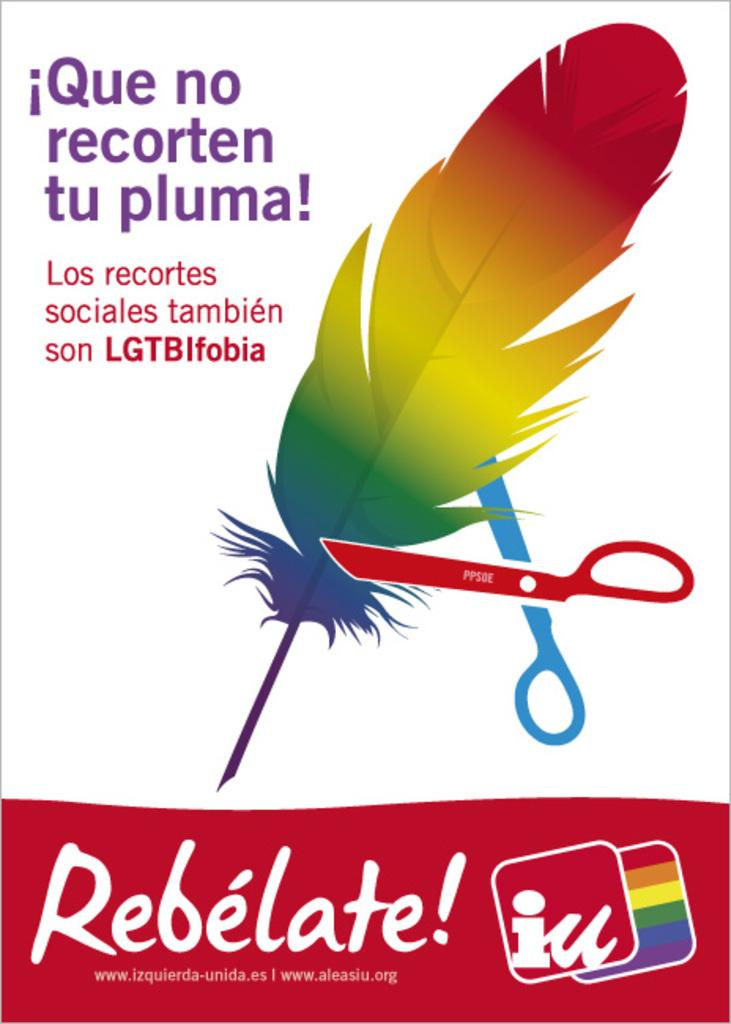<image>
Render a clear and concise summary of the photo. Poster showing a scissor cutton a feather titled "Rebelate". 